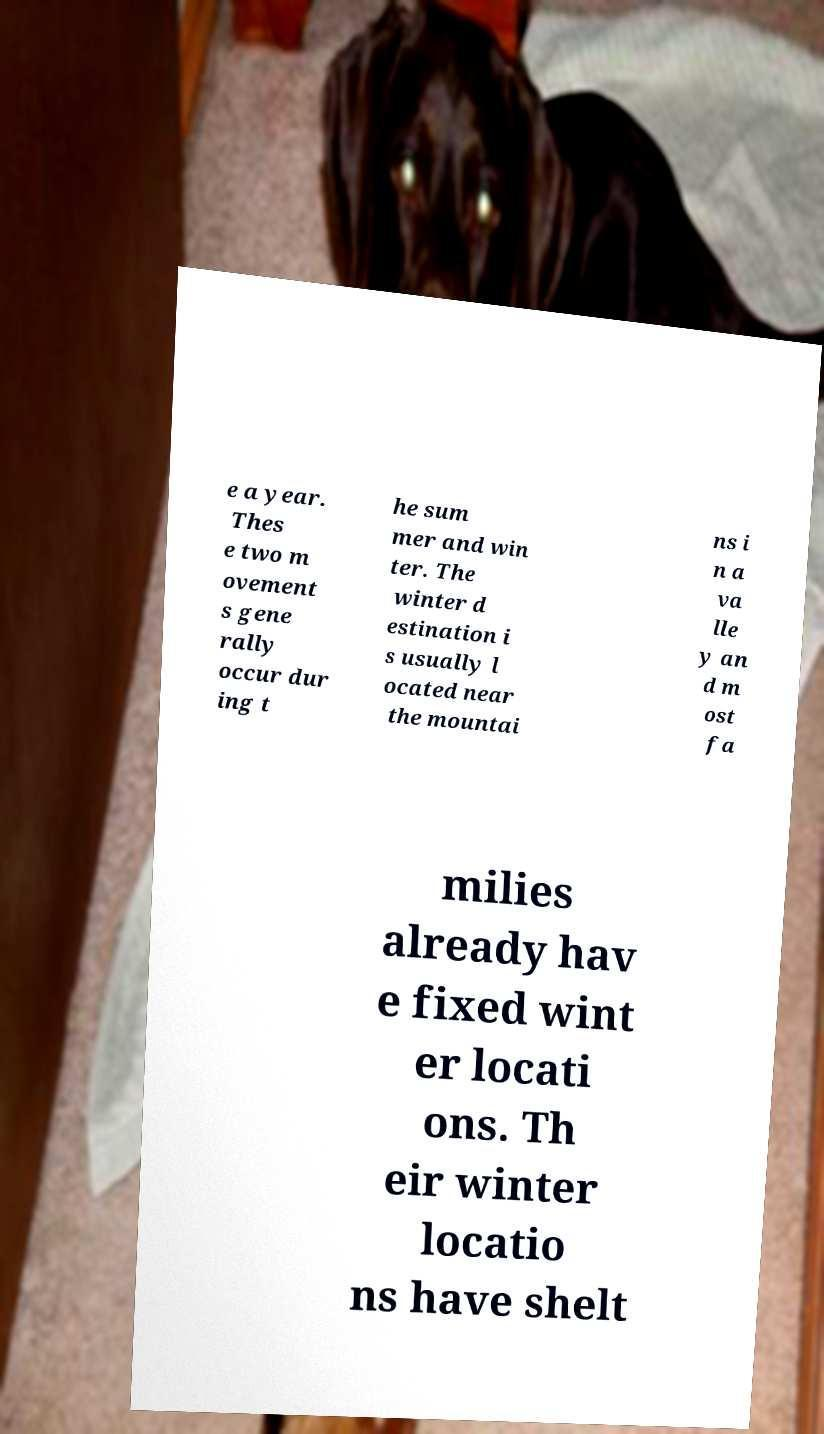Please identify and transcribe the text found in this image. e a year. Thes e two m ovement s gene rally occur dur ing t he sum mer and win ter. The winter d estination i s usually l ocated near the mountai ns i n a va lle y an d m ost fa milies already hav e fixed wint er locati ons. Th eir winter locatio ns have shelt 